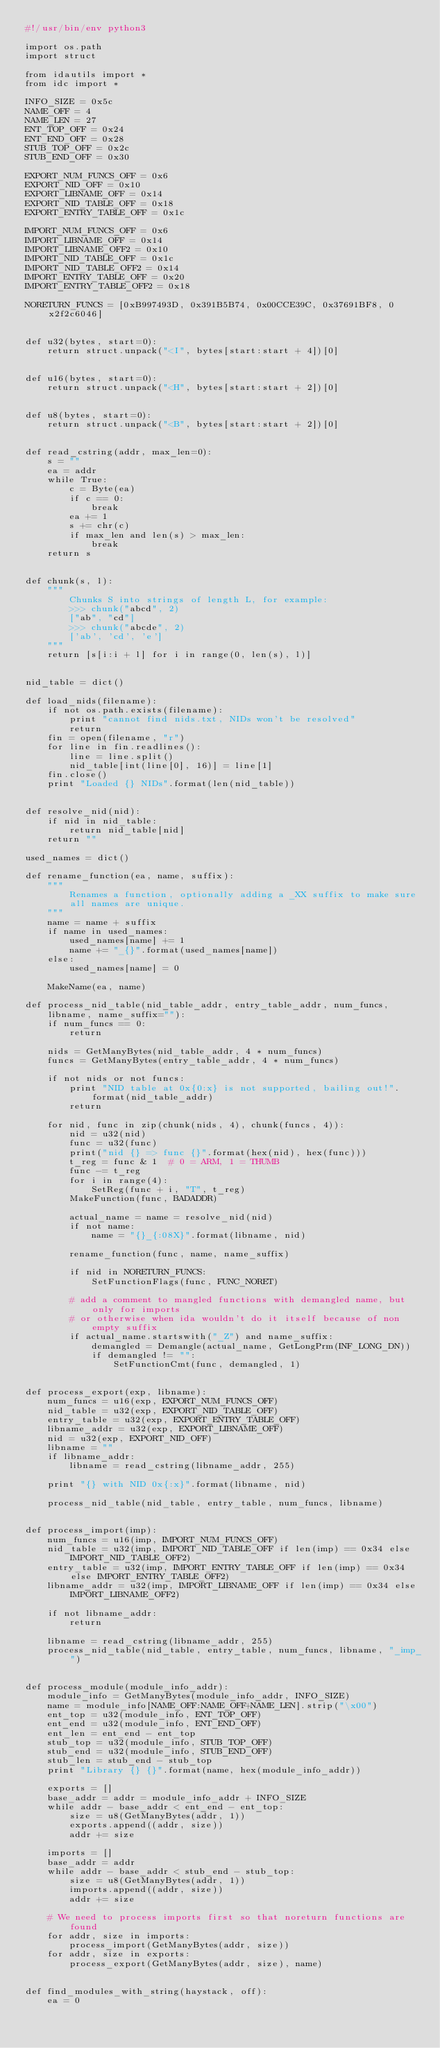Convert code to text. <code><loc_0><loc_0><loc_500><loc_500><_Python_>#!/usr/bin/env python3

import os.path
import struct

from idautils import *
from idc import *

INFO_SIZE = 0x5c
NAME_OFF = 4
NAME_LEN = 27
ENT_TOP_OFF = 0x24
ENT_END_OFF = 0x28
STUB_TOP_OFF = 0x2c
STUB_END_OFF = 0x30

EXPORT_NUM_FUNCS_OFF = 0x6
EXPORT_NID_OFF = 0x10
EXPORT_LIBNAME_OFF = 0x14
EXPORT_NID_TABLE_OFF = 0x18
EXPORT_ENTRY_TABLE_OFF = 0x1c

IMPORT_NUM_FUNCS_OFF = 0x6
IMPORT_LIBNAME_OFF = 0x14
IMPORT_LIBNAME_OFF2 = 0x10
IMPORT_NID_TABLE_OFF = 0x1c
IMPORT_NID_TABLE_OFF2 = 0x14
IMPORT_ENTRY_TABLE_OFF = 0x20
IMPORT_ENTRY_TABLE_OFF2 = 0x18

NORETURN_FUNCS = [0xB997493D, 0x391B5B74, 0x00CCE39C, 0x37691BF8, 0x2f2c6046]


def u32(bytes, start=0):
    return struct.unpack("<I", bytes[start:start + 4])[0]


def u16(bytes, start=0):
    return struct.unpack("<H", bytes[start:start + 2])[0]


def u8(bytes, start=0):
    return struct.unpack("<B", bytes[start:start + 2])[0]


def read_cstring(addr, max_len=0):
    s = ""
    ea = addr
    while True:
        c = Byte(ea)
        if c == 0:
            break
        ea += 1
        s += chr(c)
        if max_len and len(s) > max_len:
            break
    return s


def chunk(s, l):
    """
        Chunks S into strings of length L, for example:
        >>> chunk("abcd", 2)
        ["ab", "cd"]
        >>> chunk("abcde", 2)
        ['ab', 'cd', 'e']
    """
    return [s[i:i + l] for i in range(0, len(s), l)]


nid_table = dict()

def load_nids(filename):
    if not os.path.exists(filename):
        print "cannot find nids.txt, NIDs won't be resolved"
        return
    fin = open(filename, "r")
    for line in fin.readlines():
        line = line.split()
        nid_table[int(line[0], 16)] = line[1]
    fin.close()
    print "Loaded {} NIDs".format(len(nid_table))


def resolve_nid(nid):
    if nid in nid_table:
        return nid_table[nid]
    return ""

used_names = dict()

def rename_function(ea, name, suffix):
    """
        Renames a function, optionally adding a _XX suffix to make sure
        all names are unique.
    """
    name = name + suffix
    if name in used_names:
        used_names[name] += 1
        name += "_{}".format(used_names[name])
    else:
        used_names[name] = 0

    MakeName(ea, name)

def process_nid_table(nid_table_addr, entry_table_addr, num_funcs, libname, name_suffix=""):
    if num_funcs == 0:
        return

    nids = GetManyBytes(nid_table_addr, 4 * num_funcs)
    funcs = GetManyBytes(entry_table_addr, 4 * num_funcs)

    if not nids or not funcs:
        print "NID table at 0x{0:x} is not supported, bailing out!".format(nid_table_addr)
        return

    for nid, func in zip(chunk(nids, 4), chunk(funcs, 4)):
        nid = u32(nid)
        func = u32(func)
        print("nid {} => func {}".format(hex(nid), hex(func)))
        t_reg = func & 1  # 0 = ARM, 1 = THUMB
        func -= t_reg
        for i in range(4):
            SetReg(func + i, "T", t_reg)
        MakeFunction(func, BADADDR)

        actual_name = name = resolve_nid(nid)
        if not name:
            name = "{}_{:08X}".format(libname, nid)

        rename_function(func, name, name_suffix)

        if nid in NORETURN_FUNCS:
            SetFunctionFlags(func, FUNC_NORET)

        # add a comment to mangled functions with demangled name, but only for imports
        # or otherwise when ida wouldn't do it itself because of non empty suffix
        if actual_name.startswith("_Z") and name_suffix:
            demangled = Demangle(actual_name, GetLongPrm(INF_LONG_DN))
            if demangled != "":
                SetFunctionCmt(func, demangled, 1)


def process_export(exp, libname):
    num_funcs = u16(exp, EXPORT_NUM_FUNCS_OFF)
    nid_table = u32(exp, EXPORT_NID_TABLE_OFF)
    entry_table = u32(exp, EXPORT_ENTRY_TABLE_OFF)
    libname_addr = u32(exp, EXPORT_LIBNAME_OFF)
    nid = u32(exp, EXPORT_NID_OFF)
    libname = ""
    if libname_addr:
        libname = read_cstring(libname_addr, 255)

    print "{} with NID 0x{:x}".format(libname, nid)

    process_nid_table(nid_table, entry_table, num_funcs, libname)


def process_import(imp):
    num_funcs = u16(imp, IMPORT_NUM_FUNCS_OFF)
    nid_table = u32(imp, IMPORT_NID_TABLE_OFF if len(imp) == 0x34 else IMPORT_NID_TABLE_OFF2)
    entry_table = u32(imp, IMPORT_ENTRY_TABLE_OFF if len(imp) == 0x34 else IMPORT_ENTRY_TABLE_OFF2)
    libname_addr = u32(imp, IMPORT_LIBNAME_OFF if len(imp) == 0x34 else IMPORT_LIBNAME_OFF2)

    if not libname_addr:
        return

    libname = read_cstring(libname_addr, 255)
    process_nid_table(nid_table, entry_table, num_funcs, libname, "_imp_")


def process_module(module_info_addr):
    module_info = GetManyBytes(module_info_addr, INFO_SIZE)
    name = module_info[NAME_OFF:NAME_OFF+NAME_LEN].strip("\x00")
    ent_top = u32(module_info, ENT_TOP_OFF)
    ent_end = u32(module_info, ENT_END_OFF)
    ent_len = ent_end - ent_top
    stub_top = u32(module_info, STUB_TOP_OFF)
    stub_end = u32(module_info, STUB_END_OFF)
    stub_len = stub_end - stub_top
    print "Library {} {}".format(name, hex(module_info_addr))

    exports = []
    base_addr = addr = module_info_addr + INFO_SIZE
    while addr - base_addr < ent_end - ent_top:
        size = u8(GetManyBytes(addr, 1))
        exports.append((addr, size))
        addr += size

    imports = []
    base_addr = addr
    while addr - base_addr < stub_end - stub_top:
        size = u8(GetManyBytes(addr, 1))
        imports.append((addr, size))
        addr += size

    # We need to process imports first so that noreturn functions are found
    for addr, size in imports:
        process_import(GetManyBytes(addr, size))
    for addr, size in exports:
        process_export(GetManyBytes(addr, size), name)


def find_modules_with_string(haystack, off):
    ea = 0</code> 